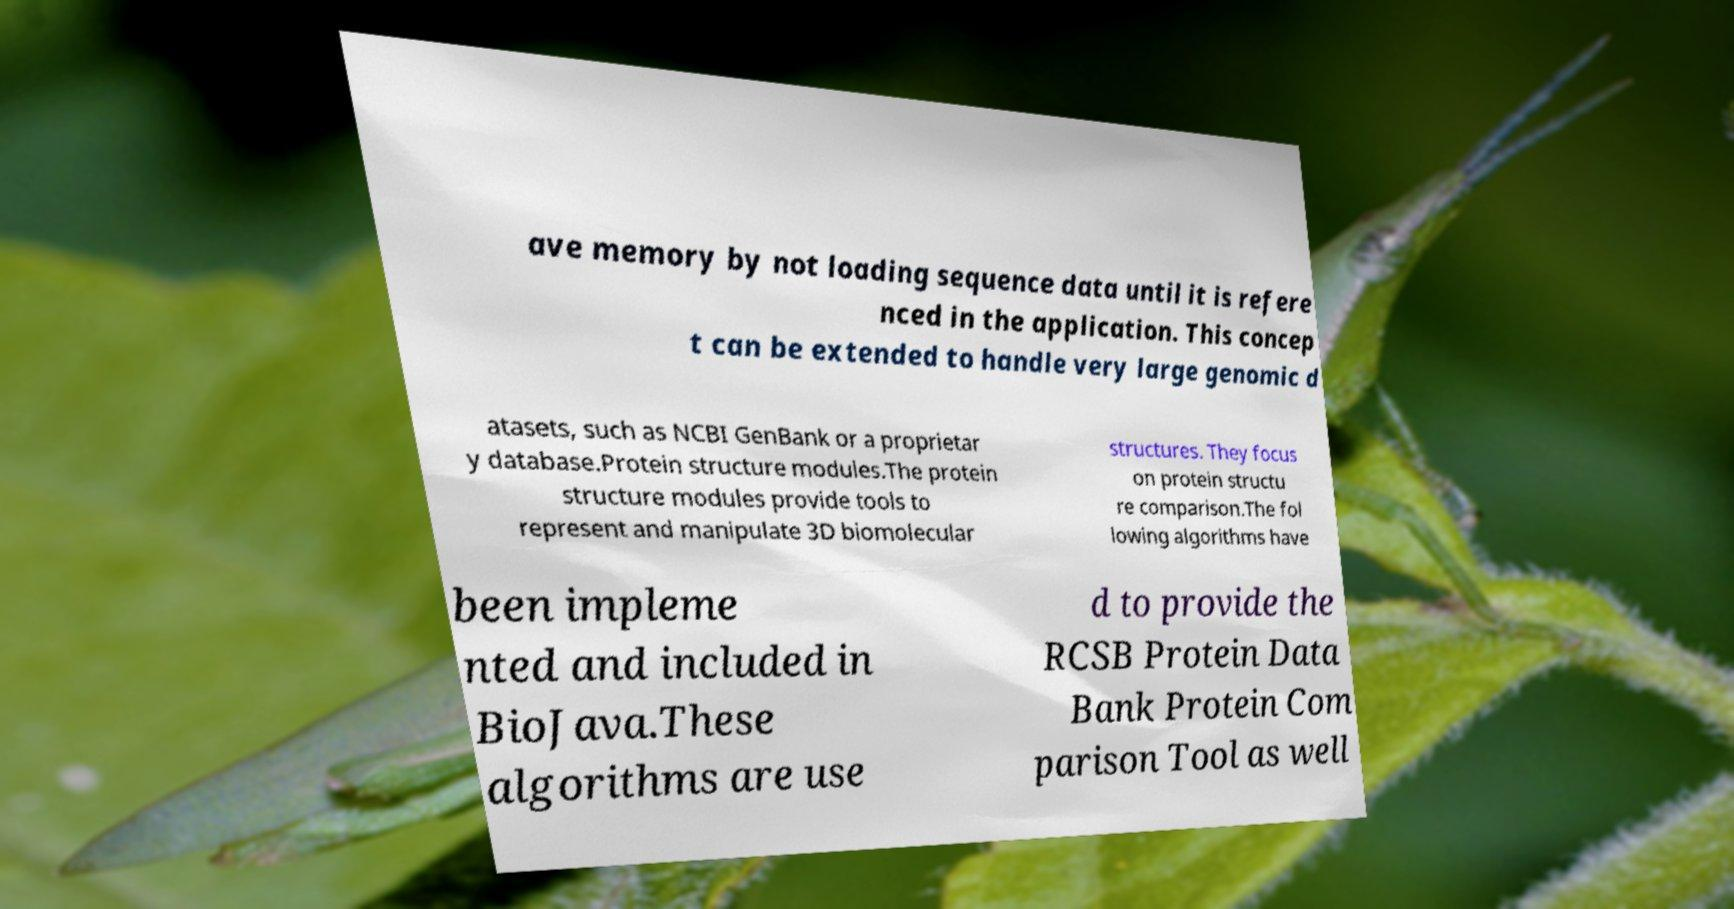Please read and relay the text visible in this image. What does it say? ave memory by not loading sequence data until it is refere nced in the application. This concep t can be extended to handle very large genomic d atasets, such as NCBI GenBank or a proprietar y database.Protein structure modules.The protein structure modules provide tools to represent and manipulate 3D biomolecular structures. They focus on protein structu re comparison.The fol lowing algorithms have been impleme nted and included in BioJava.These algorithms are use d to provide the RCSB Protein Data Bank Protein Com parison Tool as well 